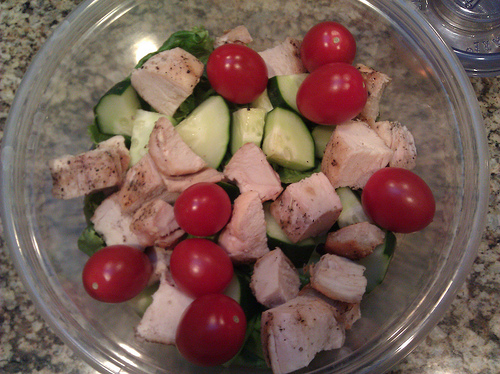<image>
Can you confirm if the cucumber is on the tomato? No. The cucumber is not positioned on the tomato. They may be near each other, but the cucumber is not supported by or resting on top of the tomato. 